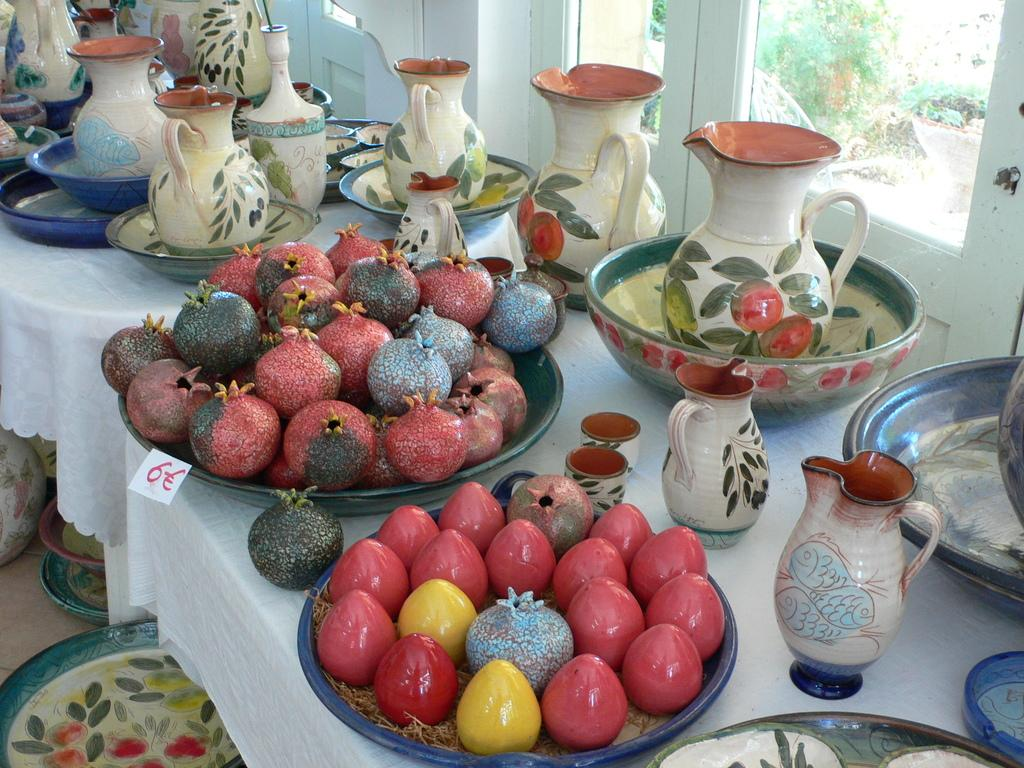What type of furniture is present in the image? There is a table in the image. What is depicted on the table? The table has painted pomegranates and kiwis. Are there any other objects on the table? Yes, there is a jar in a bowl on the table. Where is the playground located in the image? There is no playground present in the image. What type of cheese is being served on the table? There is no cheese present in the image; the table has painted pomegranates and kiwis, as well as a jar in a bowl. 